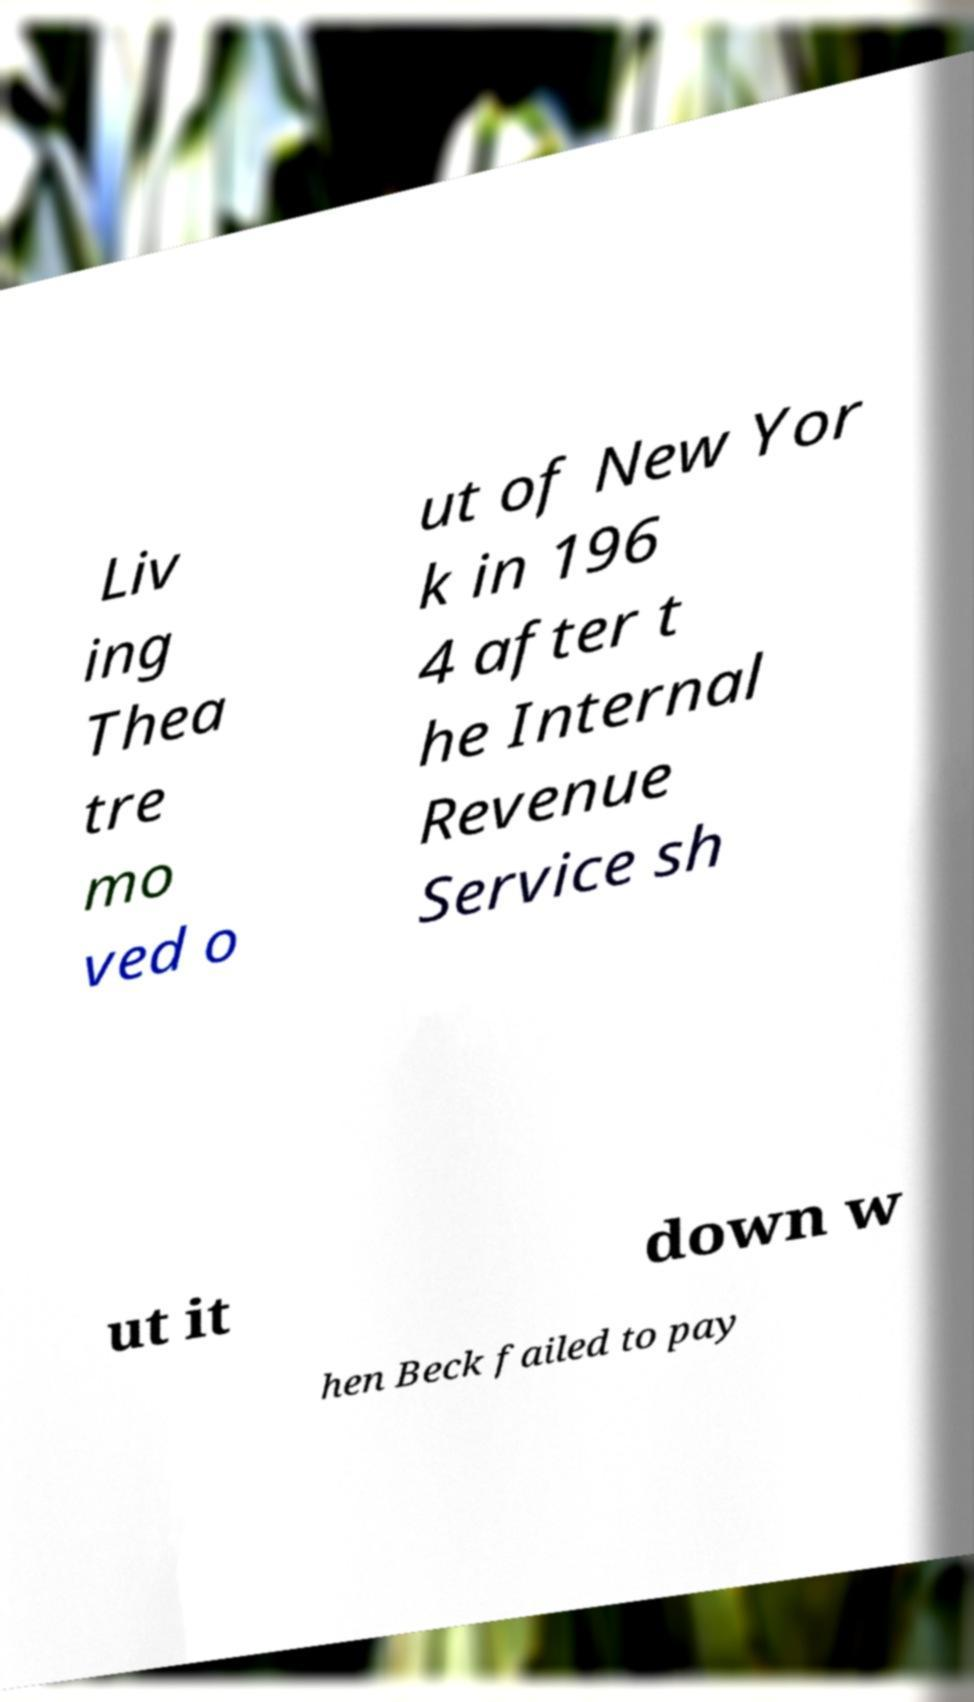Please identify and transcribe the text found in this image. Liv ing Thea tre mo ved o ut of New Yor k in 196 4 after t he Internal Revenue Service sh ut it down w hen Beck failed to pay 